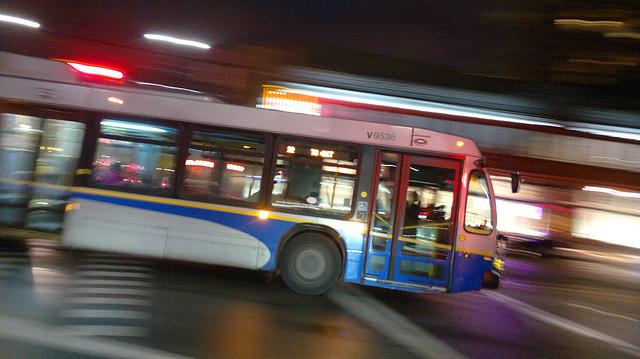Is this bus in transit during daytime hours?
Keep it brief. No. Is the bus moving?
Answer briefly. Yes. How many wheels are in the picture?
Concise answer only. 1. 